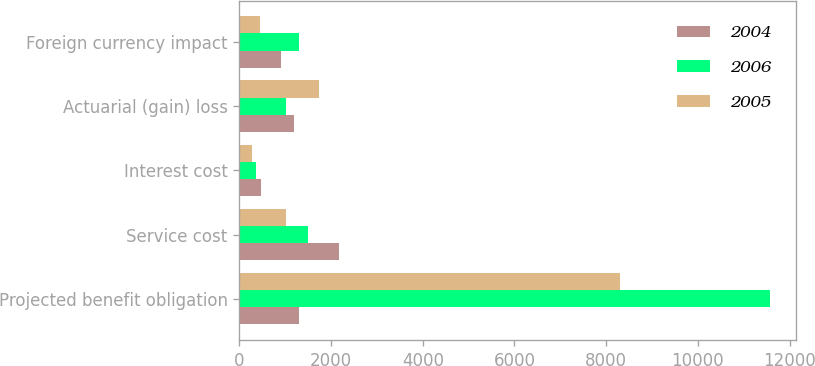<chart> <loc_0><loc_0><loc_500><loc_500><stacked_bar_chart><ecel><fcel>Projected benefit obligation<fcel>Service cost<fcel>Interest cost<fcel>Actuarial (gain) loss<fcel>Foreign currency impact<nl><fcel>2004<fcel>1304<fcel>2163<fcel>471<fcel>1192<fcel>917<nl><fcel>2006<fcel>11569<fcel>1502<fcel>353<fcel>1019<fcel>1304<nl><fcel>2005<fcel>8300<fcel>1024<fcel>280<fcel>1738<fcel>458<nl></chart> 